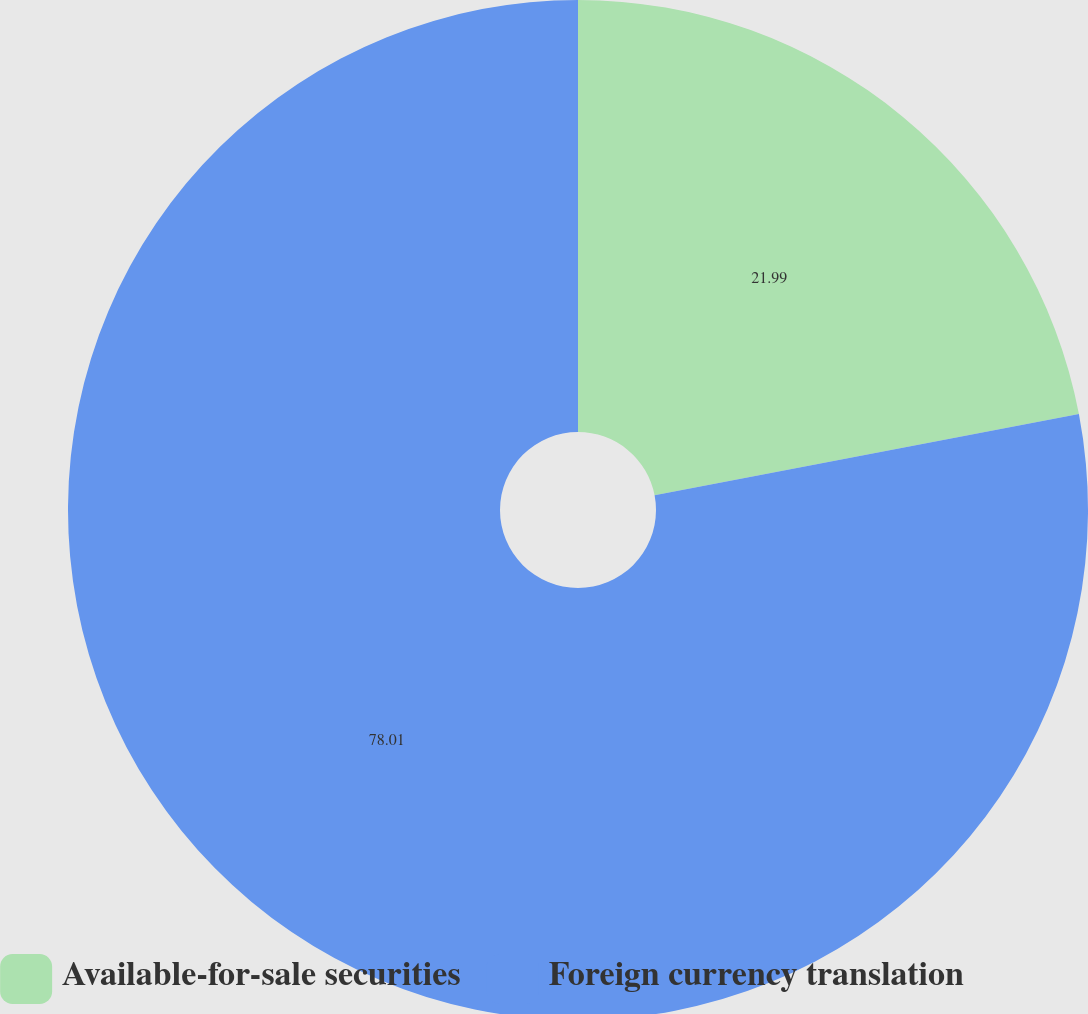Convert chart. <chart><loc_0><loc_0><loc_500><loc_500><pie_chart><fcel>Available-for-sale securities<fcel>Foreign currency translation<nl><fcel>21.99%<fcel>78.01%<nl></chart> 